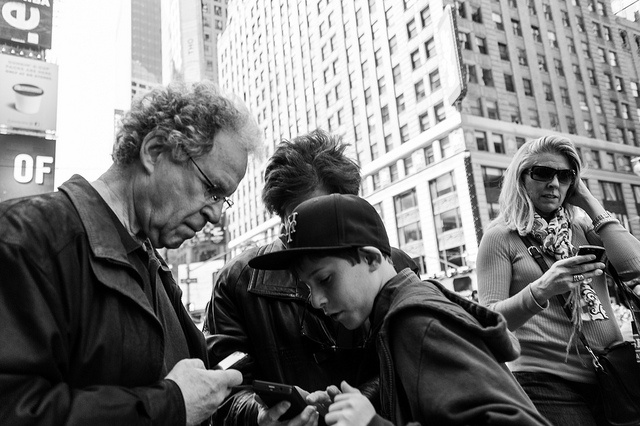Describe the objects in this image and their specific colors. I can see people in gray, black, darkgray, and lightgray tones, people in gray, black, darkgray, and lightgray tones, people in gray, black, darkgray, and lightgray tones, people in gray, black, darkgray, and lightgray tones, and handbag in gray, black, darkgray, and lightgray tones in this image. 